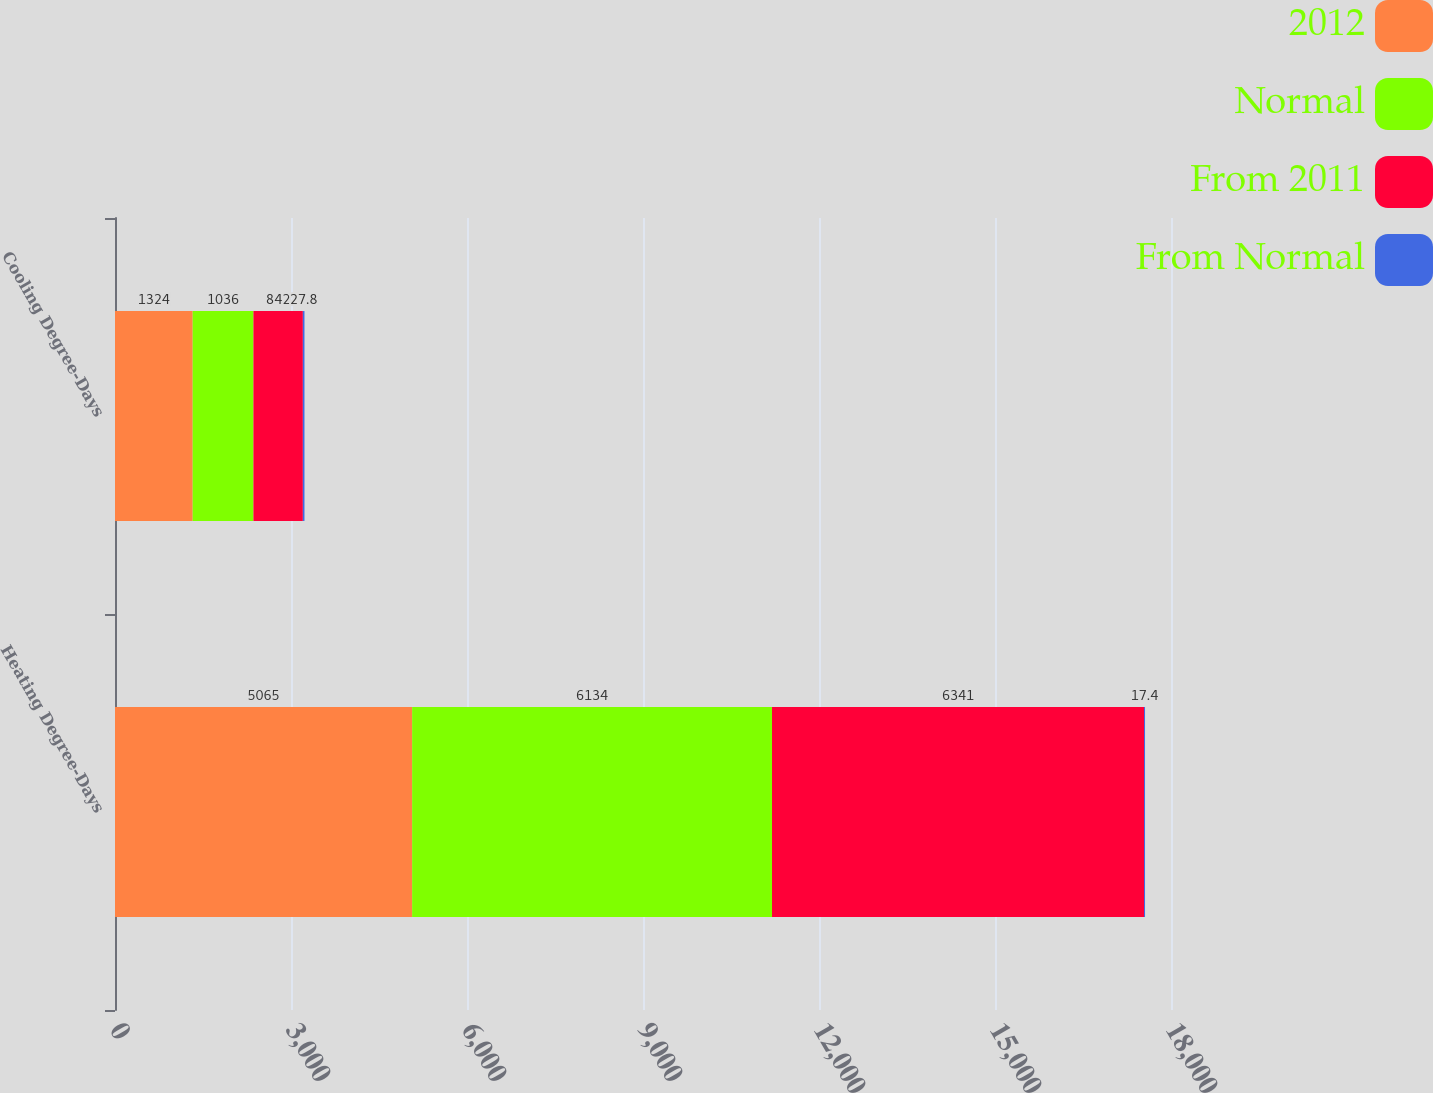Convert chart. <chart><loc_0><loc_0><loc_500><loc_500><stacked_bar_chart><ecel><fcel>Heating Degree-Days<fcel>Cooling Degree-Days<nl><fcel>2012<fcel>5065<fcel>1324<nl><fcel>Normal<fcel>6134<fcel>1036<nl><fcel>From 2011<fcel>6341<fcel>842<nl><fcel>From Normal<fcel>17.4<fcel>27.8<nl></chart> 